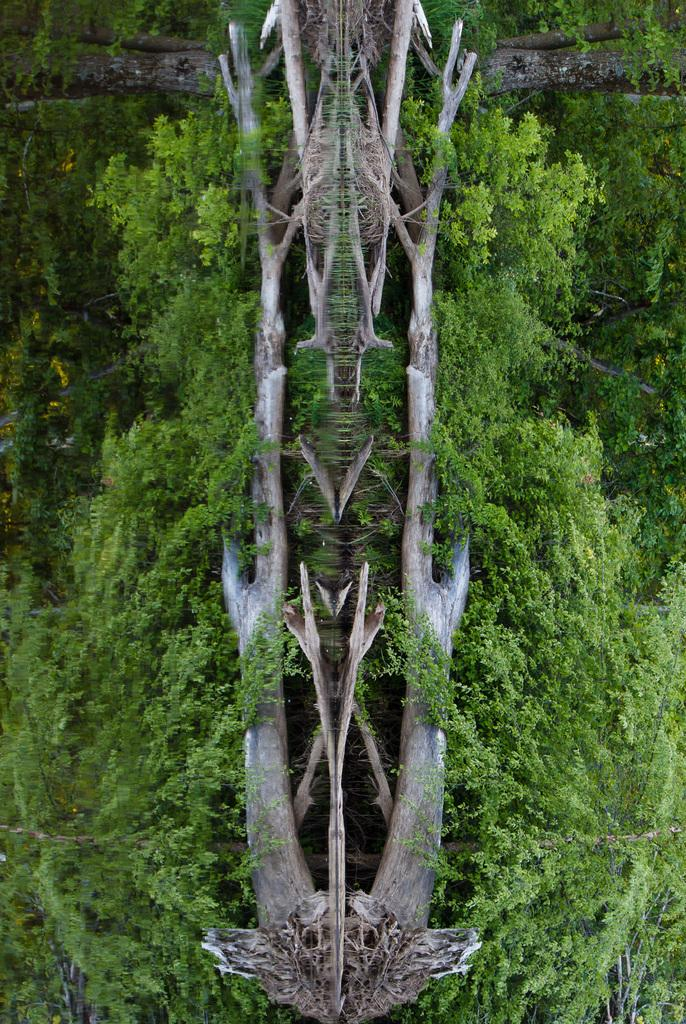What type of material is visible in the image? The image contains the bark of a tree. How many trees are present in the image? There is a group of trees in the image. What type of wool can be seen on the seed in the image? There is no wool or seed present in the image; it features the bark of a tree and a group of trees. 